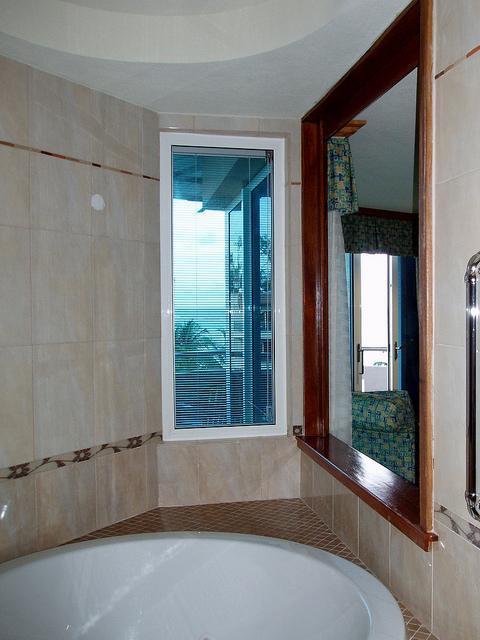How many men are holding a slice of pizza?
Give a very brief answer. 0. 